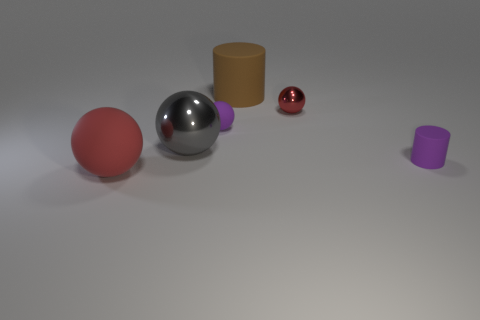Subtract all cyan balls. Subtract all green cubes. How many balls are left? 4 Add 1 large shiny things. How many objects exist? 7 Subtract all cylinders. How many objects are left? 4 Subtract all red objects. Subtract all yellow balls. How many objects are left? 4 Add 1 big metal objects. How many big metal objects are left? 2 Add 4 big brown cylinders. How many big brown cylinders exist? 5 Subtract 1 gray balls. How many objects are left? 5 